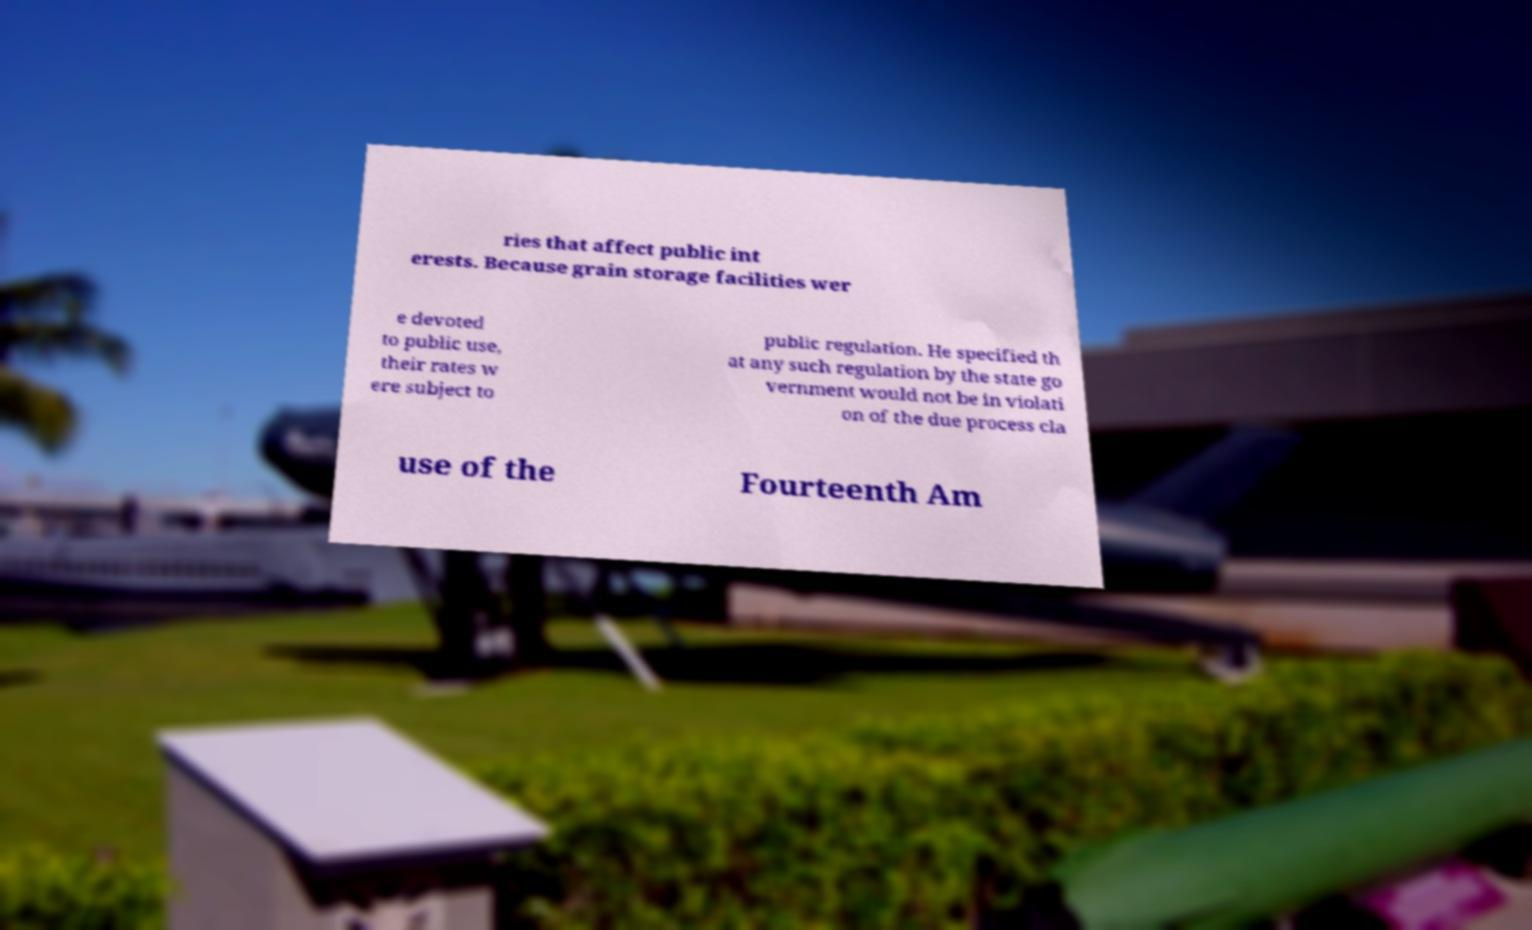Could you extract and type out the text from this image? ries that affect public int erests. Because grain storage facilities wer e devoted to public use, their rates w ere subject to public regulation. He specified th at any such regulation by the state go vernment would not be in violati on of the due process cla use of the Fourteenth Am 